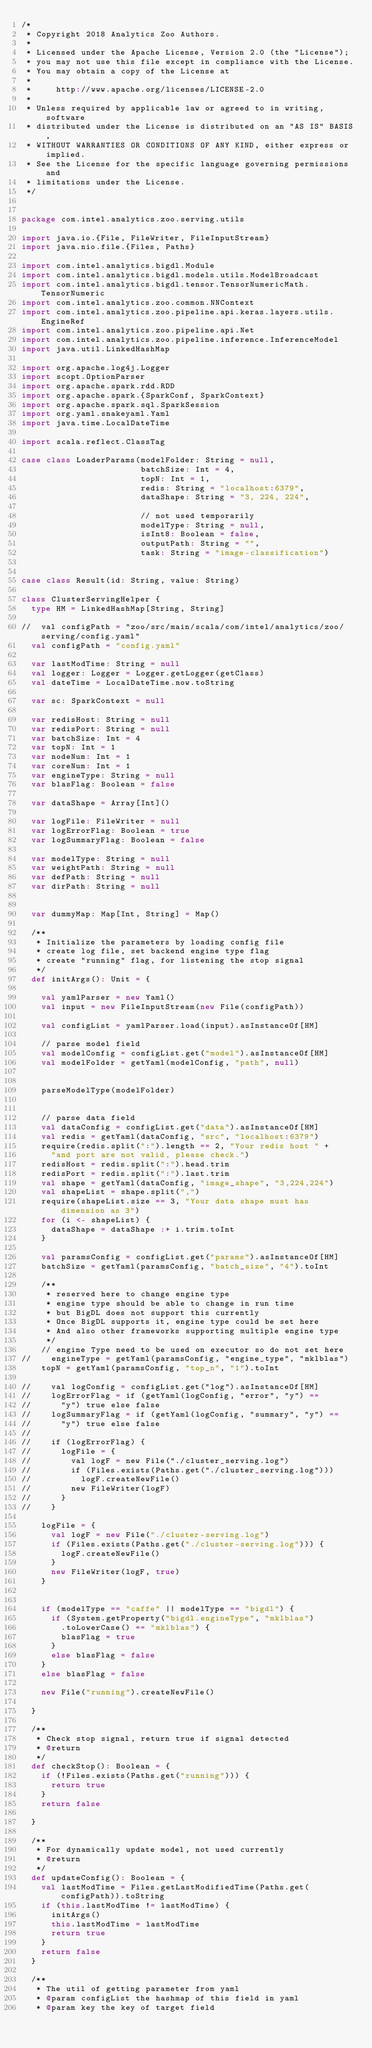<code> <loc_0><loc_0><loc_500><loc_500><_Scala_>/*
 * Copyright 2018 Analytics Zoo Authors.
 *
 * Licensed under the Apache License, Version 2.0 (the "License");
 * you may not use this file except in compliance with the License.
 * You may obtain a copy of the License at
 *
 *     http://www.apache.org/licenses/LICENSE-2.0
 *
 * Unless required by applicable law or agreed to in writing, software
 * distributed under the License is distributed on an "AS IS" BASIS,
 * WITHOUT WARRANTIES OR CONDITIONS OF ANY KIND, either express or implied.
 * See the License for the specific language governing permissions and
 * limitations under the License.
 */


package com.intel.analytics.zoo.serving.utils

import java.io.{File, FileWriter, FileInputStream}
import java.nio.file.{Files, Paths}

import com.intel.analytics.bigdl.Module
import com.intel.analytics.bigdl.models.utils.ModelBroadcast
import com.intel.analytics.bigdl.tensor.TensorNumericMath.TensorNumeric
import com.intel.analytics.zoo.common.NNContext
import com.intel.analytics.zoo.pipeline.api.keras.layers.utils.EngineRef
import com.intel.analytics.zoo.pipeline.api.Net
import com.intel.analytics.zoo.pipeline.inference.InferenceModel
import java.util.LinkedHashMap

import org.apache.log4j.Logger
import scopt.OptionParser
import org.apache.spark.rdd.RDD
import org.apache.spark.{SparkConf, SparkContext}
import org.apache.spark.sql.SparkSession
import org.yaml.snakeyaml.Yaml
import java.time.LocalDateTime

import scala.reflect.ClassTag

case class LoaderParams(modelFolder: String = null,
                        batchSize: Int = 4,
                        topN: Int = 1,
                        redis: String = "localhost:6379",
                        dataShape: String = "3, 224, 224",

                        // not used temporarily
                        modelType: String = null,
                        isInt8: Boolean = false,
                        outputPath: String = "",
                        task: String = "image-classification")


case class Result(id: String, value: String)

class ClusterServingHelper {
  type HM = LinkedHashMap[String, String]

//  val configPath = "zoo/src/main/scala/com/intel/analytics/zoo/serving/config.yaml"
  val configPath = "config.yaml"

  var lastModTime: String = null
  val logger: Logger = Logger.getLogger(getClass)
  val dateTime = LocalDateTime.now.toString

  var sc: SparkContext = null

  var redisHost: String = null
  var redisPort: String = null
  var batchSize: Int = 4
  var topN: Int = 1
  var nodeNum: Int = 1
  var coreNum: Int = 1
  var engineType: String = null
  var blasFlag: Boolean = false

  var dataShape = Array[Int]()

  var logFile: FileWriter = null
  var logErrorFlag: Boolean = true
  var logSummaryFlag: Boolean = false

  var modelType: String = null
  var weightPath: String = null
  var defPath: String = null
  var dirPath: String = null


  var dummyMap: Map[Int, String] = Map()

  /**
   * Initialize the parameters by loading config file
   * create log file, set backend engine type flag
   * create "running" flag, for listening the stop signal
   */
  def initArgs(): Unit = {

    val yamlParser = new Yaml()
    val input = new FileInputStream(new File(configPath))

    val configList = yamlParser.load(input).asInstanceOf[HM]

    // parse model field
    val modelConfig = configList.get("model").asInstanceOf[HM]
    val modelFolder = getYaml(modelConfig, "path", null)


    parseModelType(modelFolder)


    // parse data field
    val dataConfig = configList.get("data").asInstanceOf[HM]
    val redis = getYaml(dataConfig, "src", "localhost:6379")
    require(redis.split(":").length == 2, "Your redis host " +
      "and port are not valid, please check.")
    redisHost = redis.split(":").head.trim
    redisPort = redis.split(":").last.trim
    val shape = getYaml(dataConfig, "image_shape", "3,224,224")
    val shapeList = shape.split(",")
    require(shapeList.size == 3, "Your data shape must has dimension as 3")
    for (i <- shapeList) {
      dataShape = dataShape :+ i.trim.toInt
    }

    val paramsConfig = configList.get("params").asInstanceOf[HM]
    batchSize = getYaml(paramsConfig, "batch_size", "4").toInt

    /**
     * reserved here to change engine type
     * engine type should be able to change in run time
     * but BigDL does not support this currently
     * Once BigDL supports it, engine type could be set here
     * And also other frameworks supporting multiple engine type
     */
    // engine Type need to be used on executor so do not set here
//    engineType = getYaml(paramsConfig, "engine_type", "mklblas")
    topN = getYaml(paramsConfig, "top_n", "1").toInt

//    val logConfig = configList.get("log").asInstanceOf[HM]
//    logErrorFlag = if (getYaml(logConfig, "error", "y") ==
//      "y") true else false
//    logSummaryFlag = if (getYaml(logConfig, "summary", "y") ==
//      "y") true else false
//
//    if (logErrorFlag) {
//      logFile = {
//        val logF = new File("./cluster_serving.log")
//        if (Files.exists(Paths.get("./cluster_serving.log")))
//          logF.createNewFile()
//        new FileWriter(logF)
//      }
//    }

    logFile = {
      val logF = new File("./cluster-serving.log")
      if (Files.exists(Paths.get("./cluster-serving.log"))) {
        logF.createNewFile()
      }
      new FileWriter(logF, true)
    }


    if (modelType == "caffe" || modelType == "bigdl") {
      if (System.getProperty("bigdl.engineType", "mklblas")
        .toLowerCase() == "mklblas") {
        blasFlag = true
      }
      else blasFlag = false
    }
    else blasFlag = false

    new File("running").createNewFile()

  }

  /**
   * Check stop signal, return true if signal detected
   * @return
   */
  def checkStop(): Boolean = {
    if (!Files.exists(Paths.get("running"))) {
      return true
    }
    return false

  }

  /**
   * For dynamically update model, not used currently
   * @return
   */
  def updateConfig(): Boolean = {
    val lastModTime = Files.getLastModifiedTime(Paths.get(configPath)).toString
    if (this.lastModTime != lastModTime) {
      initArgs()
      this.lastModTime = lastModTime
      return true
    }
    return false
  }

  /**
   * The util of getting parameter from yaml
   * @param configList the hashmap of this field in yaml
   * @param key the key of target field</code> 